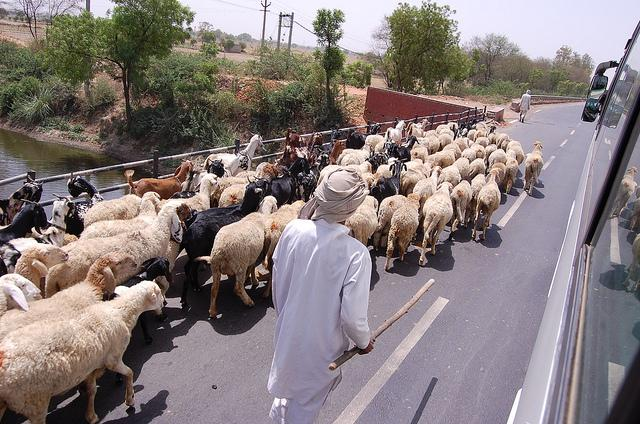What side of the rest is usually best for passing? right 